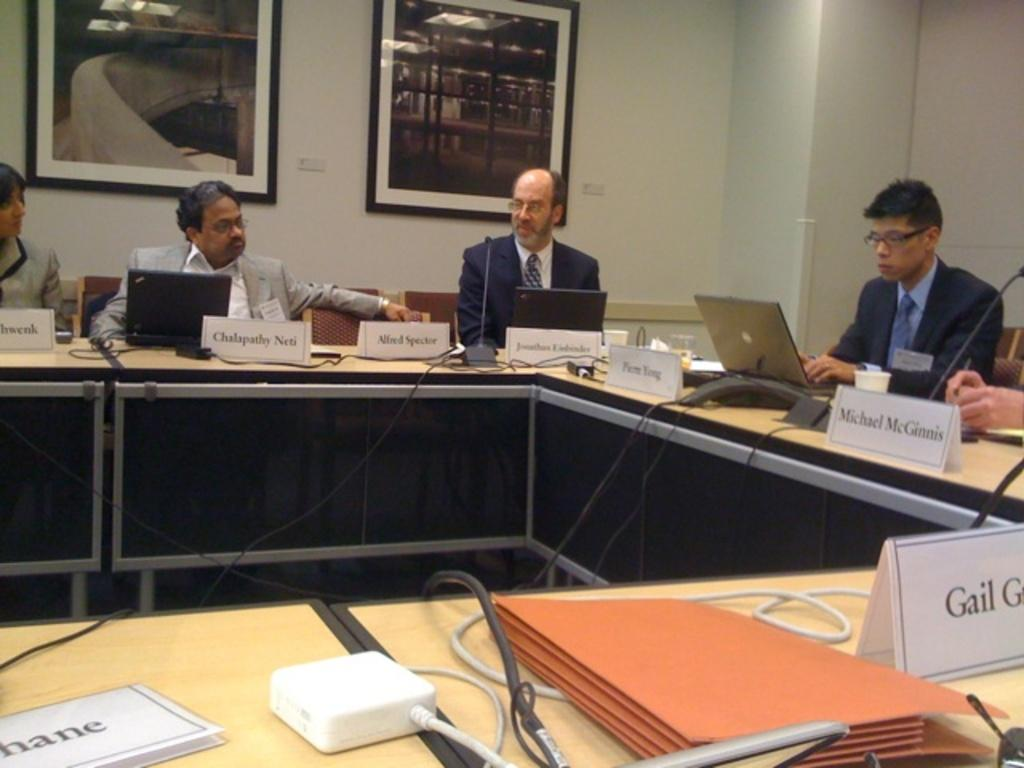<image>
Give a short and clear explanation of the subsequent image. A meeting with one of the attendees named Michael McGinnis. 